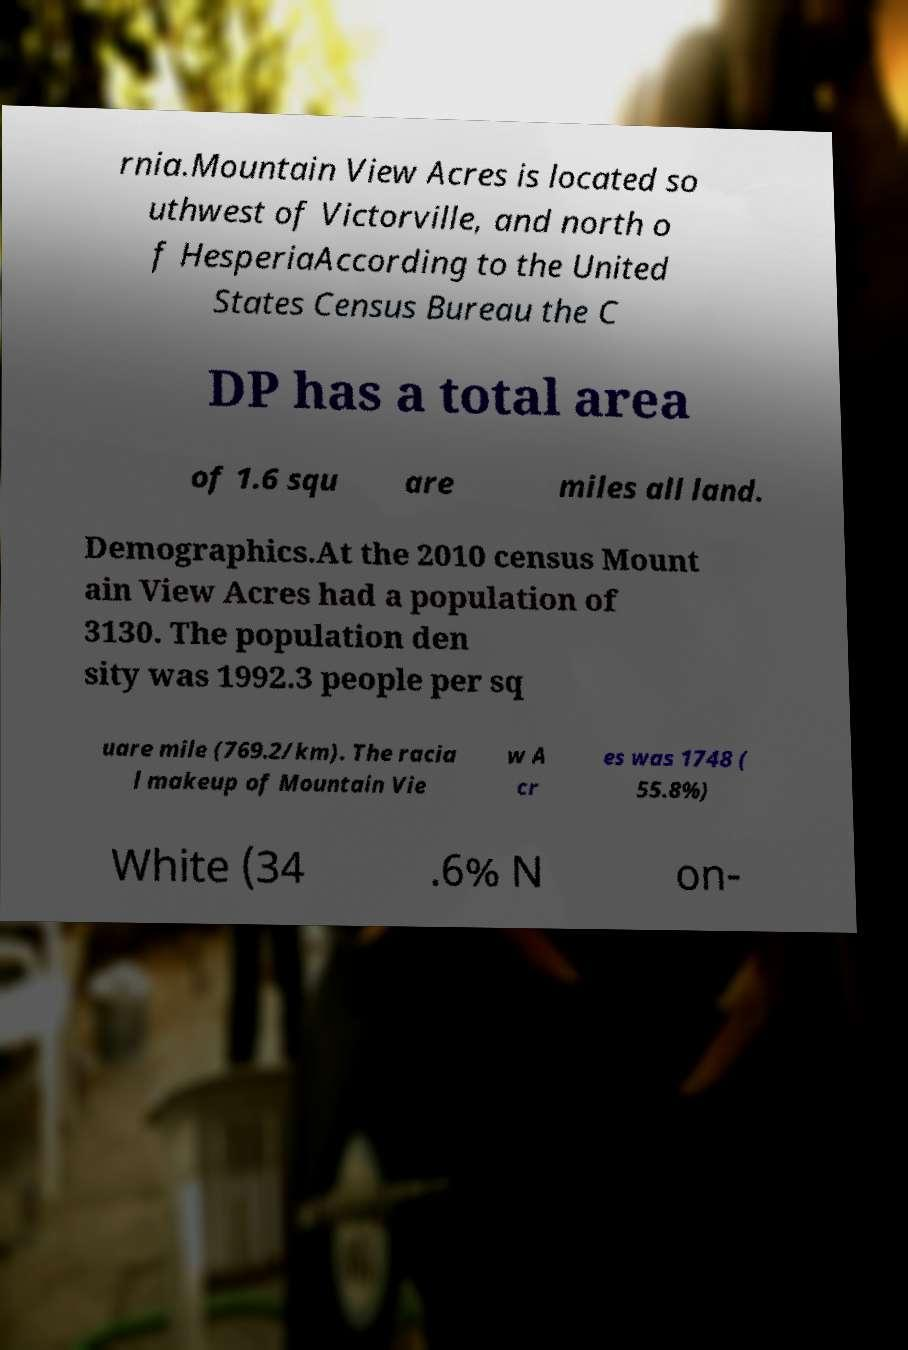I need the written content from this picture converted into text. Can you do that? rnia.Mountain View Acres is located so uthwest of Victorville, and north o f HesperiaAccording to the United States Census Bureau the C DP has a total area of 1.6 squ are miles all land. Demographics.At the 2010 census Mount ain View Acres had a population of 3130. The population den sity was 1992.3 people per sq uare mile (769.2/km). The racia l makeup of Mountain Vie w A cr es was 1748 ( 55.8%) White (34 .6% N on- 